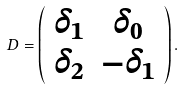<formula> <loc_0><loc_0><loc_500><loc_500>D = \left ( \begin{array} { c c } \delta _ { 1 } & \delta _ { 0 } \\ \delta _ { 2 } & - \delta _ { 1 } \end{array} \right ) .</formula> 